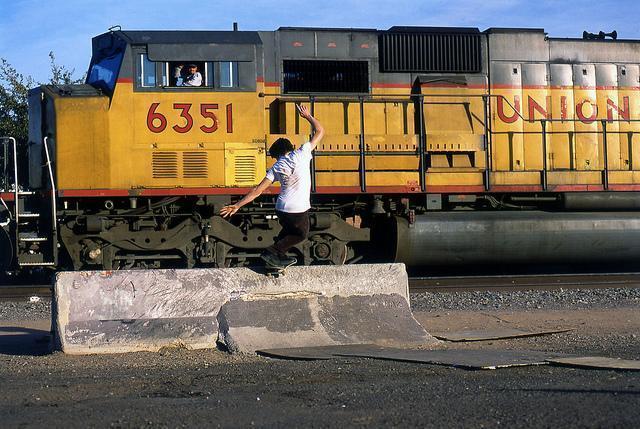Which direction did the skater just come from?
Select the accurate response from the four choices given to answer the question.
Options: Train track, train top, down, high up. Down. 